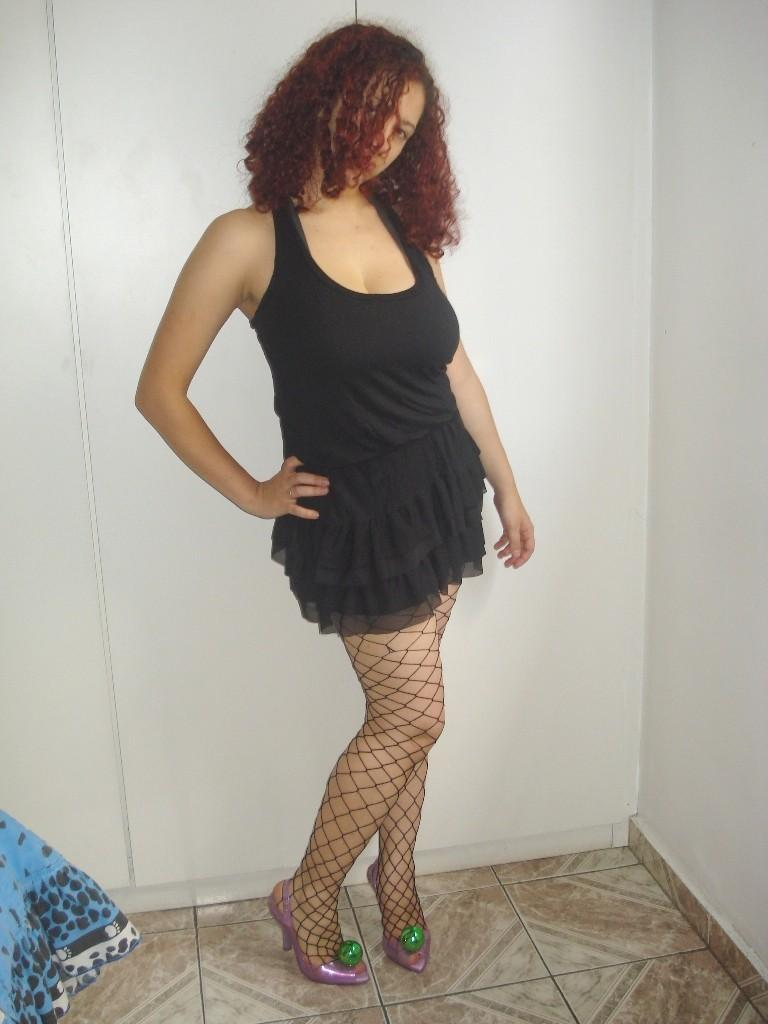Who is the main subject in the image? There is a lady in the image. What is the lady wearing? The lady is wearing a black dress. What can be seen in the background of the image? There is a wall in the background of the image. What colors are present in the left corner of the image? There is a blue and black color cloth in the left corner of the image. What is the lady's opinion on the sheet in the image? There is no sheet present in the image, so it is not possible to determine the lady's opinion on it. 